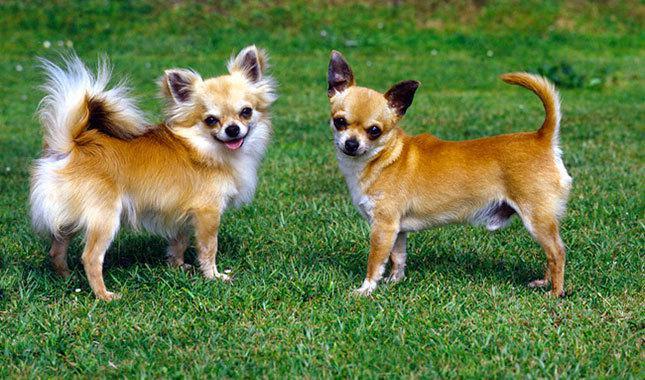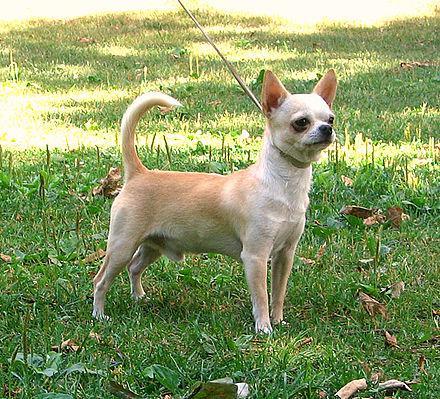The first image is the image on the left, the second image is the image on the right. Assess this claim about the two images: "Left image features two small dogs with no collars or leashes.". Correct or not? Answer yes or no. Yes. The first image is the image on the left, the second image is the image on the right. For the images shown, is this caption "One dog's tail is fluffy." true? Answer yes or no. Yes. 